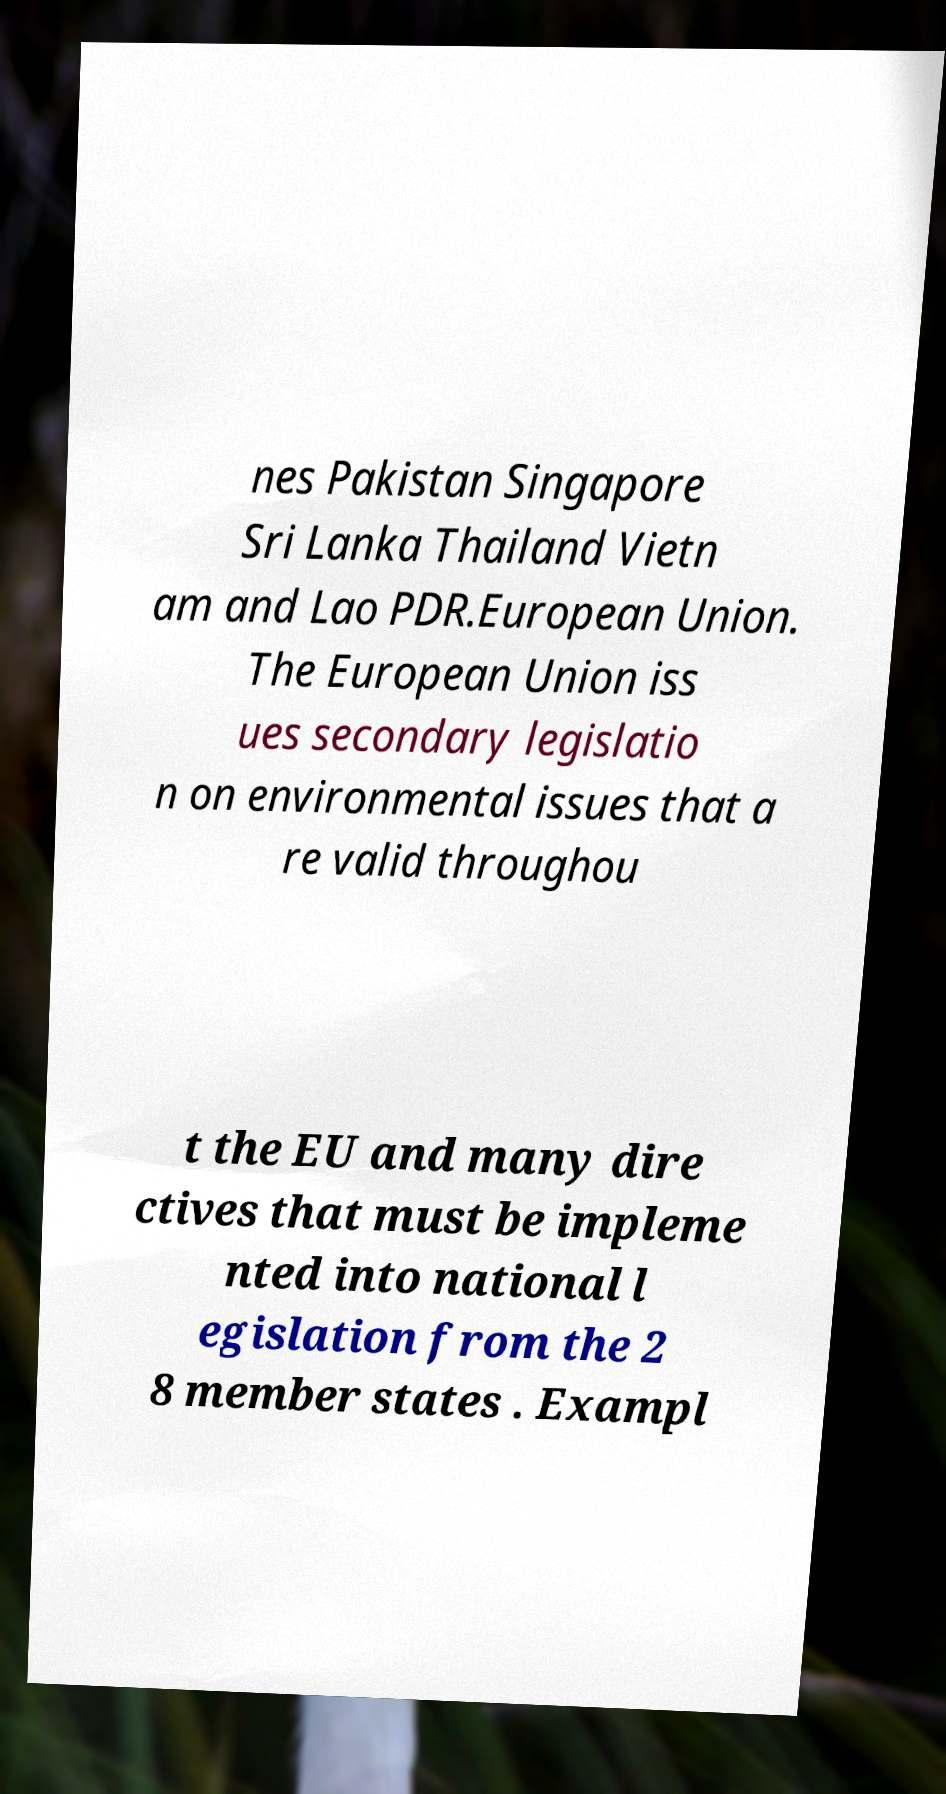What messages or text are displayed in this image? I need them in a readable, typed format. nes Pakistan Singapore Sri Lanka Thailand Vietn am and Lao PDR.European Union. The European Union iss ues secondary legislatio n on environmental issues that a re valid throughou t the EU and many dire ctives that must be impleme nted into national l egislation from the 2 8 member states . Exampl 